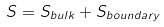<formula> <loc_0><loc_0><loc_500><loc_500>S = S _ { b u l k } + S _ { b o u n d a r y }</formula> 